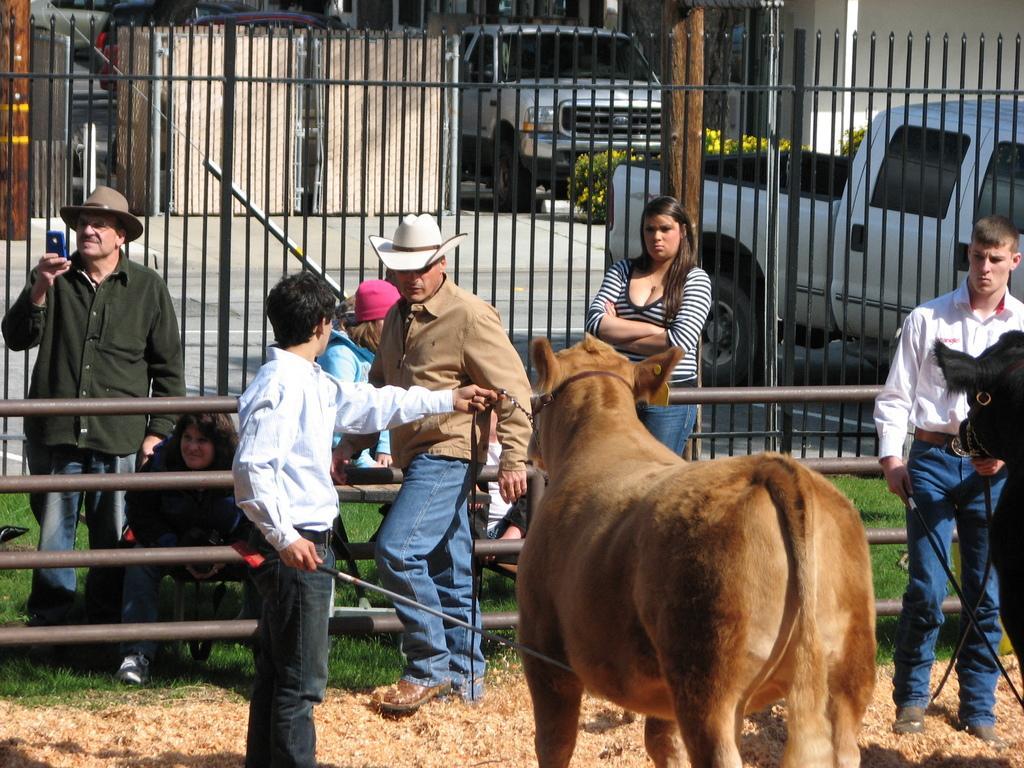Please provide a concise description of this image. In this image we can see many people. There are few people wearing hats. There is a grassy land in the image. There is a fence and a barrier in the image. There is an animal. There is a building in the image. There are few vehicles in the image. 